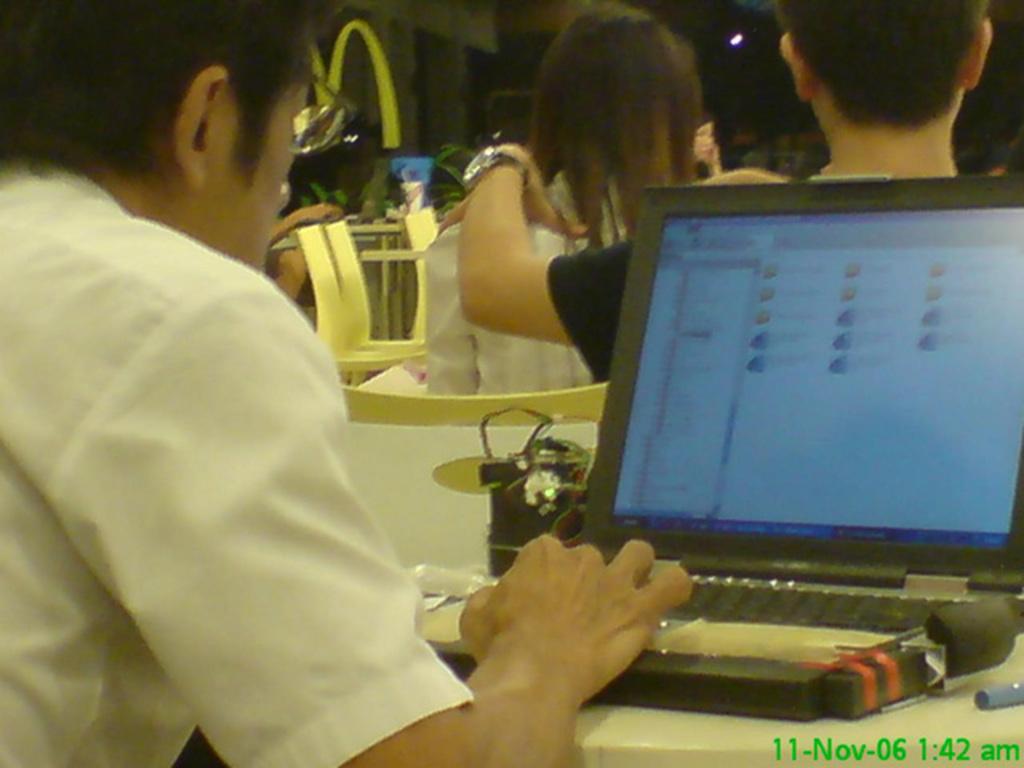Describe this image in one or two sentences. In this image we can see a person operating a laptop, he is wearing a white shirt and spectacles. There are other people at the back. 